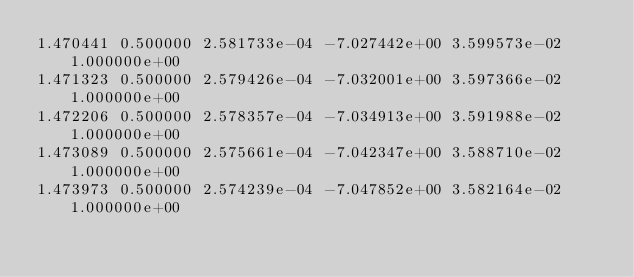Convert code to text. <code><loc_0><loc_0><loc_500><loc_500><_SQL_>1.470441 0.500000 2.581733e-04 -7.027442e+00 3.599573e-02 1.000000e+00 
1.471323 0.500000 2.579426e-04 -7.032001e+00 3.597366e-02 1.000000e+00 
1.472206 0.500000 2.578357e-04 -7.034913e+00 3.591988e-02 1.000000e+00 
1.473089 0.500000 2.575661e-04 -7.042347e+00 3.588710e-02 1.000000e+00 
1.473973 0.500000 2.574239e-04 -7.047852e+00 3.582164e-02 1.000000e+00 </code> 